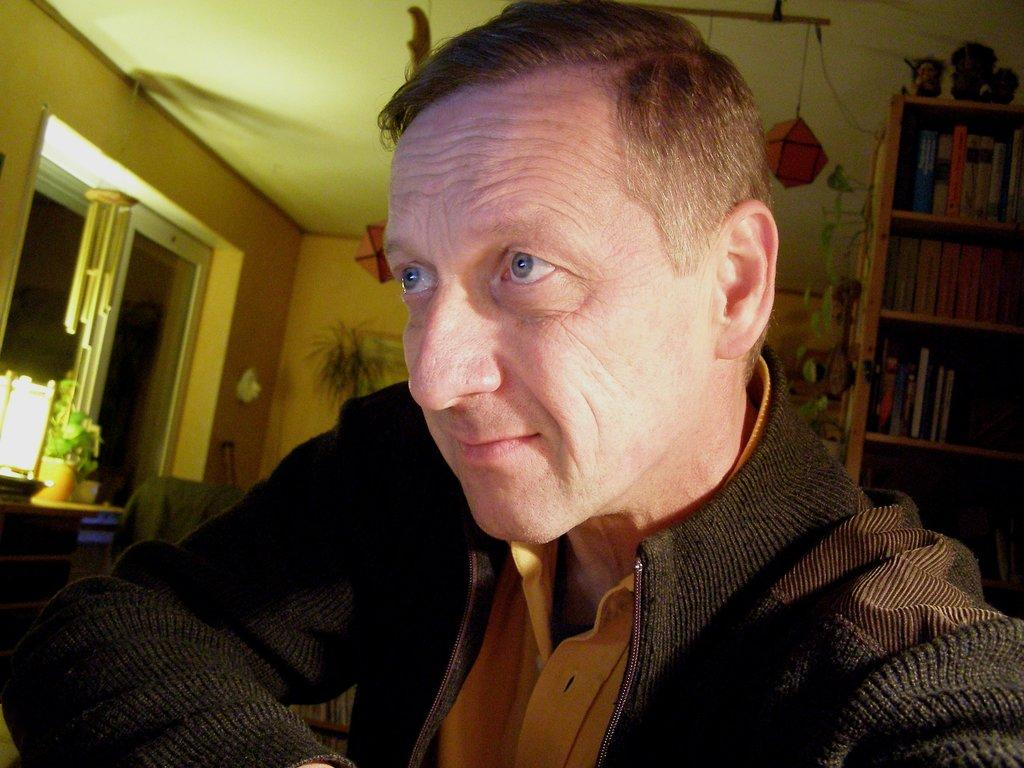What is the man in the image doing? The man is seated in the image. What is the man wearing? The man is wearing a coat. What can be seen on the bookshelf in the image? There are books on a bookshelf in the image. What type of window is present in the image? There is a glass window in the image. What is hanging in the image? A lantern is hanging in the image. What type of vegetation is present in the image? There are plants in the image. What type of behavior is the man exhibiting in the image? The image does not provide information about the man's behavior, only his position and clothing. 